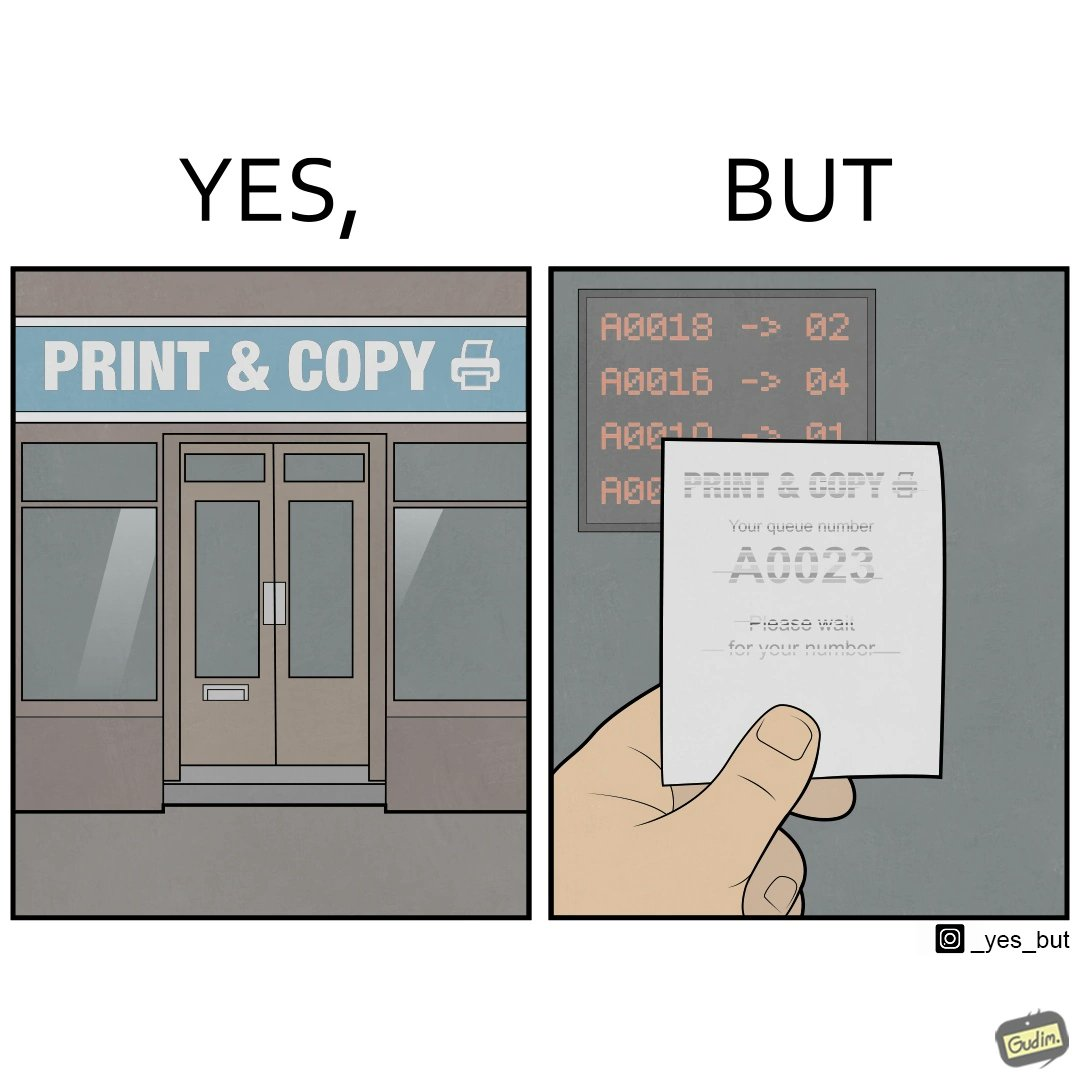Describe the contrast between the left and right parts of this image. In the left part of the image: entrance to the "Print & Copy" Centre. In the right part of the image: printed waiting slip for the 'Print & Copy" Centre. 